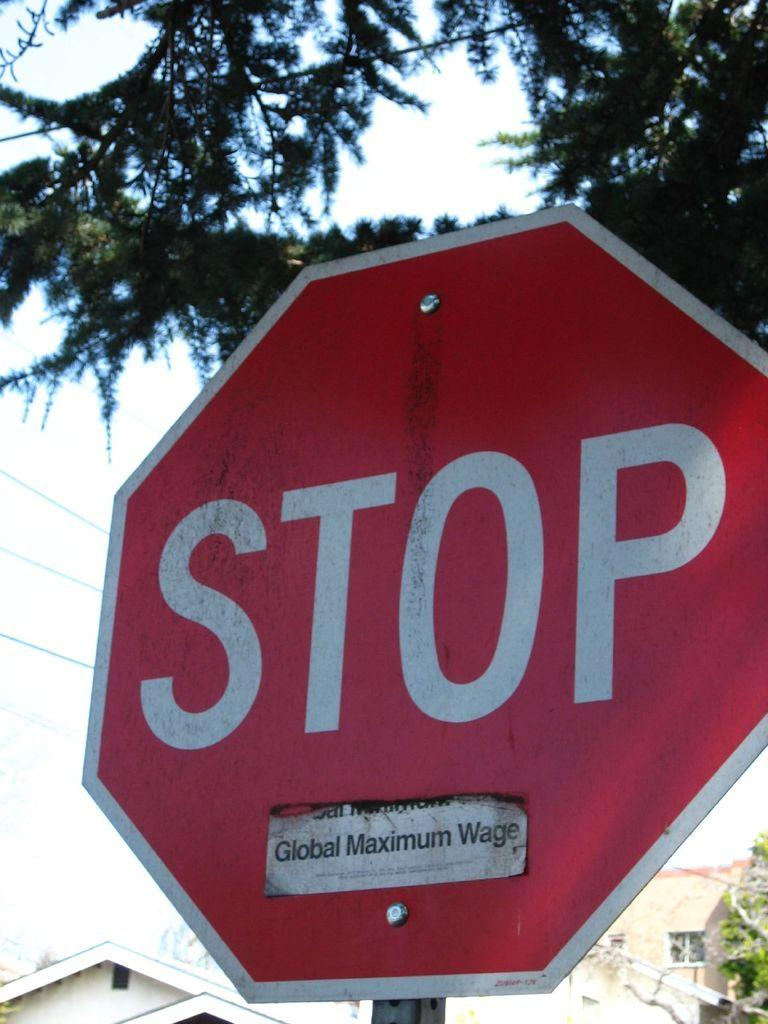<image>
Render a clear and concise summary of the photo. A Global Maximum Wage sticker has been placed on a stop sign. 